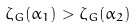Convert formula to latex. <formula><loc_0><loc_0><loc_500><loc_500>\zeta _ { G } ( \alpha _ { 1 } ) > \zeta _ { G } ( \alpha _ { 2 } )</formula> 